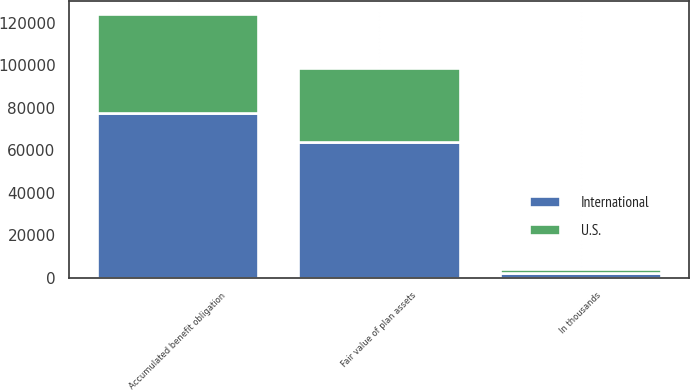Convert chart to OTSL. <chart><loc_0><loc_0><loc_500><loc_500><stacked_bar_chart><ecel><fcel>In thousands<fcel>Accumulated benefit obligation<fcel>Fair value of plan assets<nl><fcel>U.S.<fcel>2009<fcel>46472<fcel>34872<nl><fcel>International<fcel>2009<fcel>77767<fcel>64105<nl></chart> 